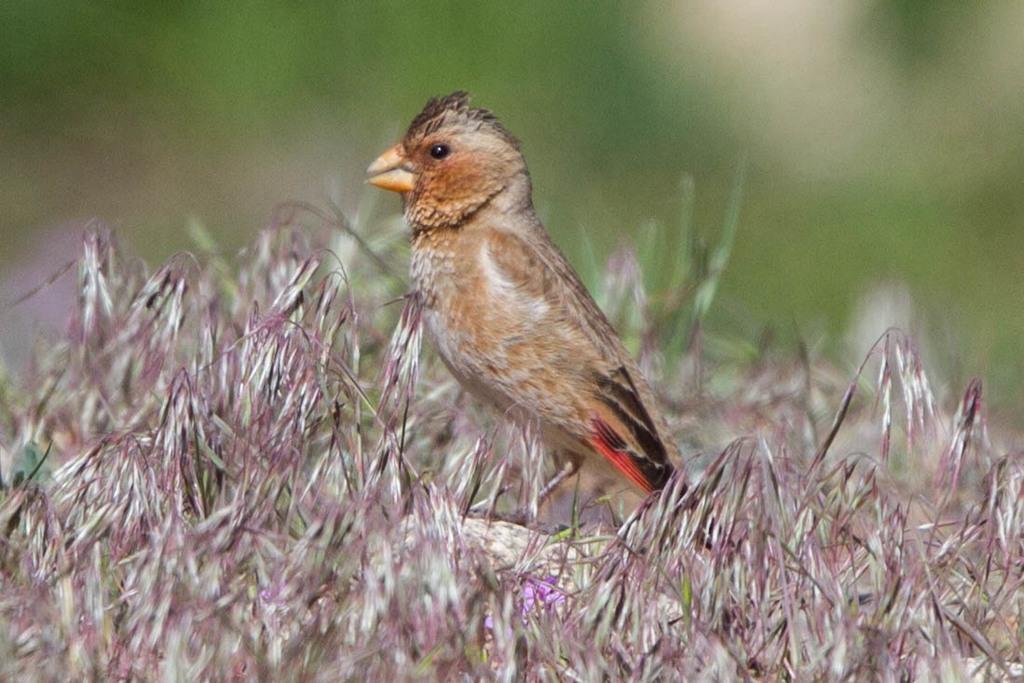How would you summarize this image in a sentence or two? In this image, we can see a bird and grass. Background we can see the blur view. Here it seems like a flower in the image. 